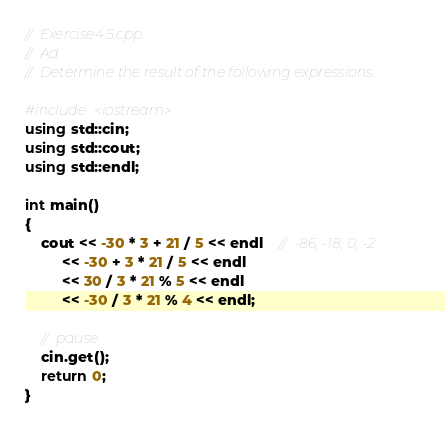<code> <loc_0><loc_0><loc_500><loc_500><_C++_>//  Exercise4.5.cpp
//  Ad
//  Determine the result of the following expressions.

#include <iostream>
using std::cin;
using std::cout;
using std::endl;

int main()
{
    cout << -30 * 3 + 21 / 5 << endl    //  -86, -18, 0, -2
         << -30 + 3 * 21 / 5 << endl
         << 30 / 3 * 21 % 5 << endl
         << -30 / 3 * 21 % 4 << endl;

    //  pause
    cin.get();
    return 0;
}</code> 